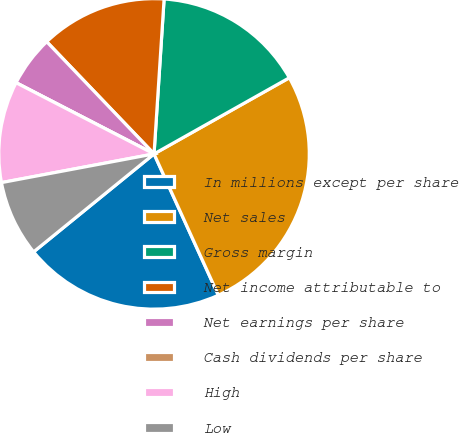Convert chart to OTSL. <chart><loc_0><loc_0><loc_500><loc_500><pie_chart><fcel>In millions except per share<fcel>Net sales<fcel>Gross margin<fcel>Net income attributable to<fcel>Net earnings per share<fcel>Cash dividends per share<fcel>High<fcel>Low<nl><fcel>20.93%<fcel>26.36%<fcel>15.81%<fcel>13.18%<fcel>5.27%<fcel>0.0%<fcel>10.54%<fcel>7.91%<nl></chart> 